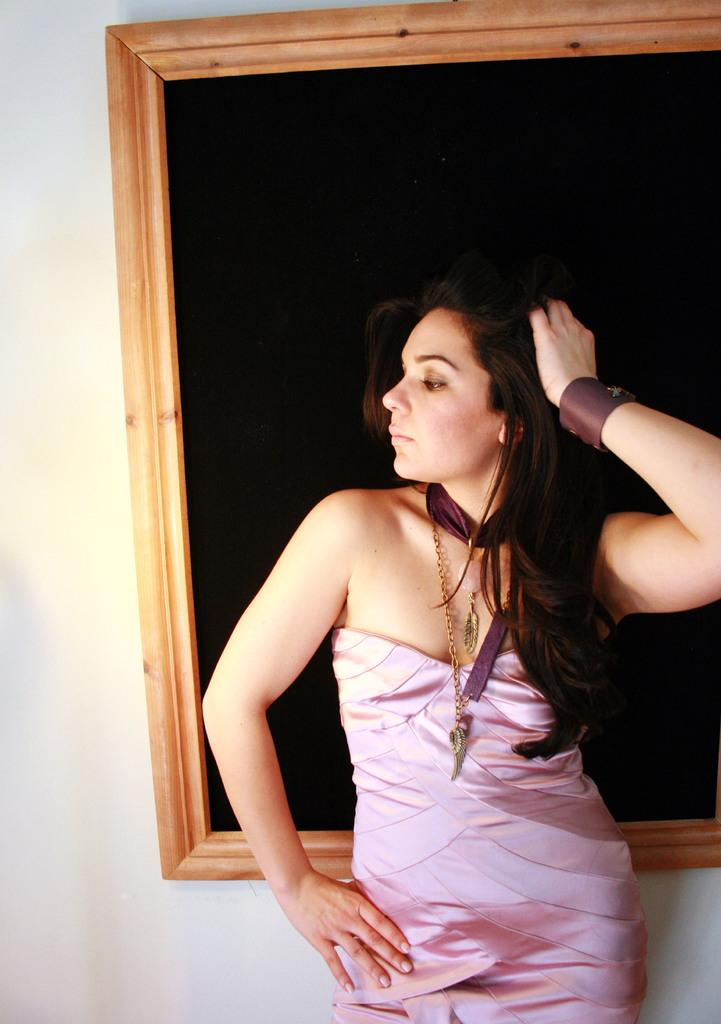What is the main subject of the image? There is a woman standing in the image. What can be seen in the background of the image? There is a wall in the background of the image. Are there any objects or features on the wall? Yes, there is a frame on the wall in the background. What type of bell is hanging from the frame in the image? There is no bell present in the image; it only features a woman standing and a frame on the wall in the background. 